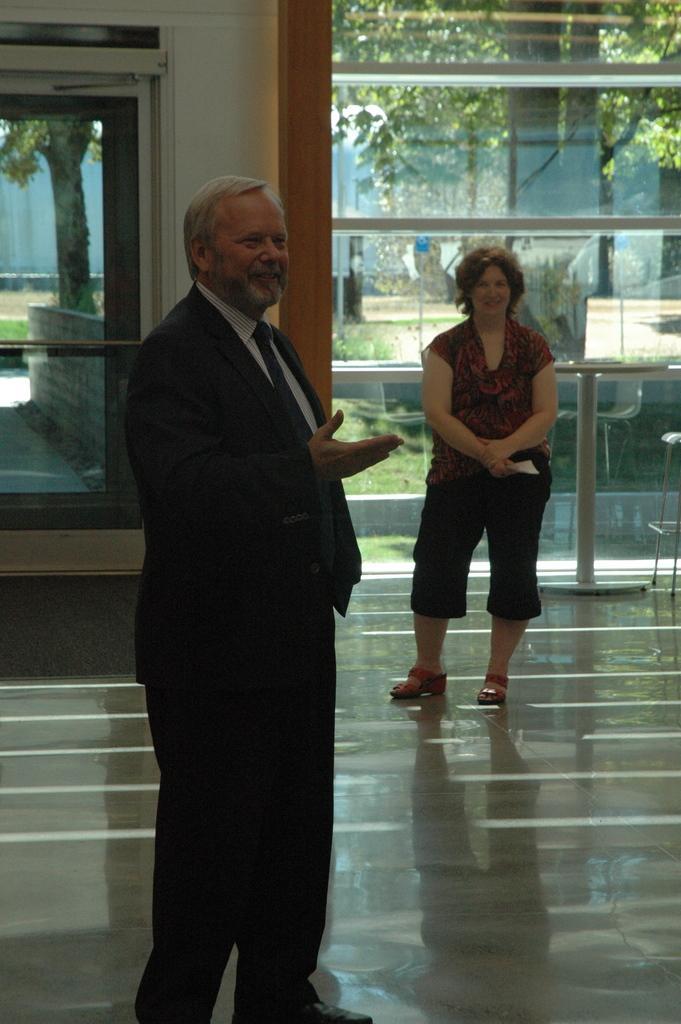Describe this image in one or two sentences. In the center of the picture is a man standing wearing a black suit. On the right there is a woman standing. In the background there is a door and a glass window, outside the window there are trees, grass and plants. 